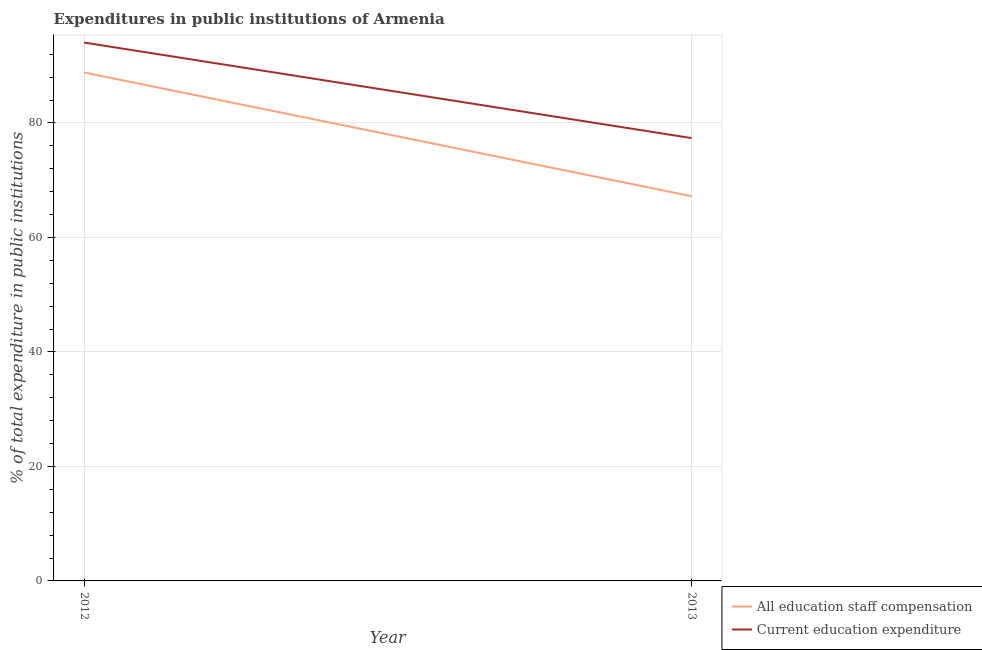What is the expenditure in education in 2013?
Provide a short and direct response. 77.35. Across all years, what is the maximum expenditure in staff compensation?
Ensure brevity in your answer.  88.81. Across all years, what is the minimum expenditure in staff compensation?
Offer a terse response. 67.2. In which year was the expenditure in education maximum?
Your answer should be compact. 2012. What is the total expenditure in staff compensation in the graph?
Your answer should be very brief. 156.02. What is the difference between the expenditure in education in 2012 and that in 2013?
Provide a succinct answer. 16.69. What is the difference between the expenditure in education in 2012 and the expenditure in staff compensation in 2013?
Provide a short and direct response. 26.84. What is the average expenditure in education per year?
Ensure brevity in your answer.  85.7. In the year 2013, what is the difference between the expenditure in education and expenditure in staff compensation?
Your response must be concise. 10.15. What is the ratio of the expenditure in education in 2012 to that in 2013?
Give a very brief answer. 1.22. How many years are there in the graph?
Your answer should be compact. 2. What is the difference between two consecutive major ticks on the Y-axis?
Ensure brevity in your answer.  20. Does the graph contain any zero values?
Make the answer very short. No. Does the graph contain grids?
Your answer should be very brief. Yes. Where does the legend appear in the graph?
Offer a very short reply. Bottom right. How are the legend labels stacked?
Your answer should be very brief. Vertical. What is the title of the graph?
Make the answer very short. Expenditures in public institutions of Armenia. Does "Methane emissions" appear as one of the legend labels in the graph?
Make the answer very short. No. What is the label or title of the X-axis?
Ensure brevity in your answer.  Year. What is the label or title of the Y-axis?
Provide a short and direct response. % of total expenditure in public institutions. What is the % of total expenditure in public institutions in All education staff compensation in 2012?
Offer a very short reply. 88.81. What is the % of total expenditure in public institutions of Current education expenditure in 2012?
Provide a succinct answer. 94.04. What is the % of total expenditure in public institutions of All education staff compensation in 2013?
Your answer should be very brief. 67.2. What is the % of total expenditure in public institutions in Current education expenditure in 2013?
Your response must be concise. 77.35. Across all years, what is the maximum % of total expenditure in public institutions of All education staff compensation?
Ensure brevity in your answer.  88.81. Across all years, what is the maximum % of total expenditure in public institutions in Current education expenditure?
Offer a terse response. 94.04. Across all years, what is the minimum % of total expenditure in public institutions of All education staff compensation?
Ensure brevity in your answer.  67.2. Across all years, what is the minimum % of total expenditure in public institutions in Current education expenditure?
Provide a short and direct response. 77.35. What is the total % of total expenditure in public institutions in All education staff compensation in the graph?
Ensure brevity in your answer.  156.02. What is the total % of total expenditure in public institutions of Current education expenditure in the graph?
Offer a terse response. 171.39. What is the difference between the % of total expenditure in public institutions of All education staff compensation in 2012 and that in 2013?
Ensure brevity in your answer.  21.61. What is the difference between the % of total expenditure in public institutions of Current education expenditure in 2012 and that in 2013?
Provide a succinct answer. 16.69. What is the difference between the % of total expenditure in public institutions of All education staff compensation in 2012 and the % of total expenditure in public institutions of Current education expenditure in 2013?
Provide a succinct answer. 11.46. What is the average % of total expenditure in public institutions of All education staff compensation per year?
Your answer should be very brief. 78.01. What is the average % of total expenditure in public institutions in Current education expenditure per year?
Offer a very short reply. 85.7. In the year 2012, what is the difference between the % of total expenditure in public institutions of All education staff compensation and % of total expenditure in public institutions of Current education expenditure?
Keep it short and to the point. -5.23. In the year 2013, what is the difference between the % of total expenditure in public institutions of All education staff compensation and % of total expenditure in public institutions of Current education expenditure?
Give a very brief answer. -10.15. What is the ratio of the % of total expenditure in public institutions of All education staff compensation in 2012 to that in 2013?
Keep it short and to the point. 1.32. What is the ratio of the % of total expenditure in public institutions of Current education expenditure in 2012 to that in 2013?
Offer a very short reply. 1.22. What is the difference between the highest and the second highest % of total expenditure in public institutions in All education staff compensation?
Provide a short and direct response. 21.61. What is the difference between the highest and the second highest % of total expenditure in public institutions of Current education expenditure?
Offer a terse response. 16.69. What is the difference between the highest and the lowest % of total expenditure in public institutions in All education staff compensation?
Give a very brief answer. 21.61. What is the difference between the highest and the lowest % of total expenditure in public institutions of Current education expenditure?
Your answer should be very brief. 16.69. 